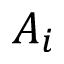Convert formula to latex. <formula><loc_0><loc_0><loc_500><loc_500>A _ { i }</formula> 